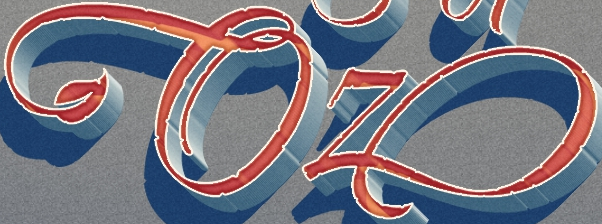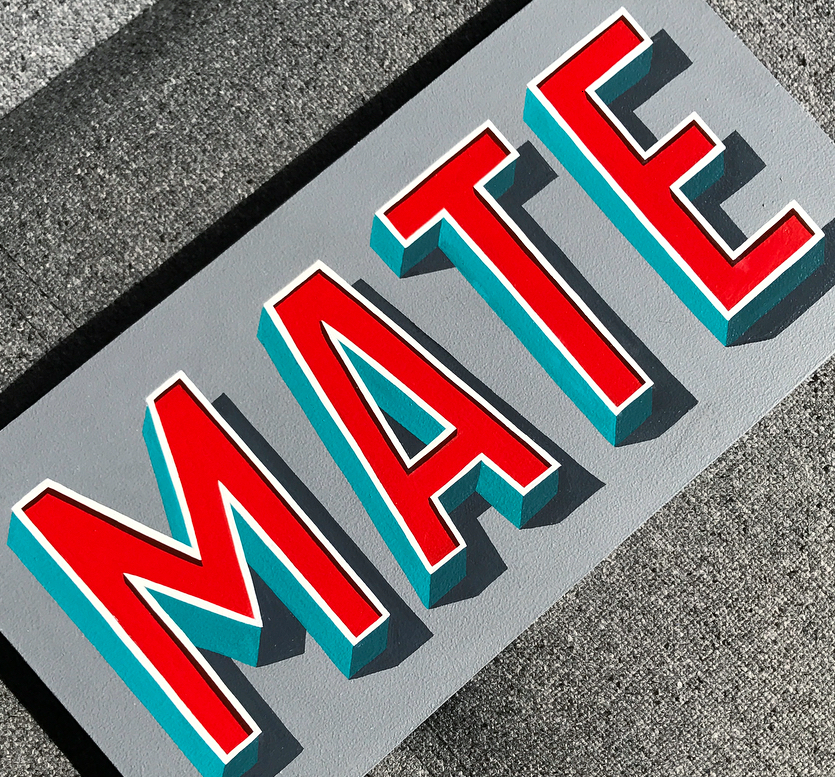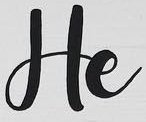What words can you see in these images in sequence, separated by a semicolon? Oz; MATE; He 